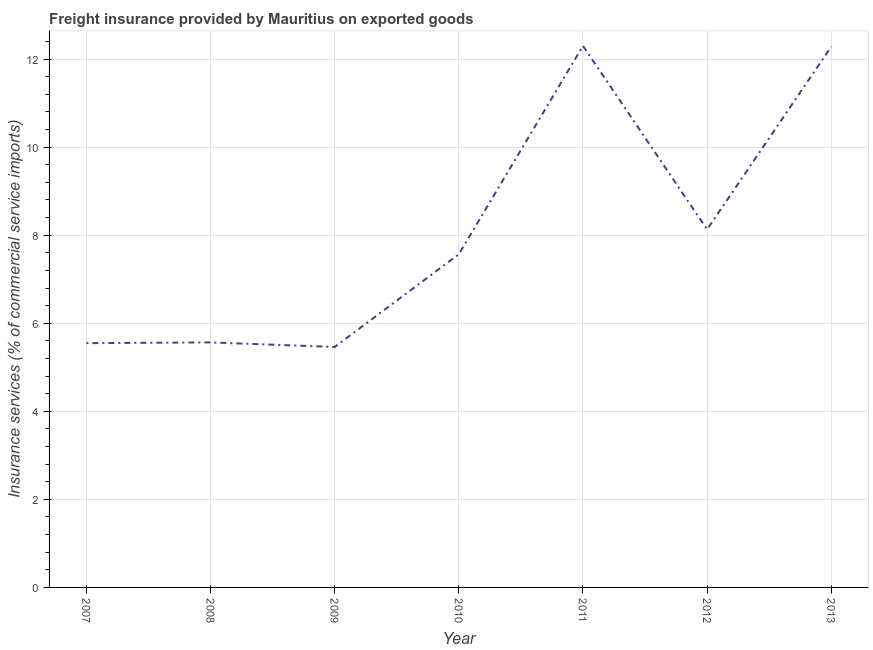What is the freight insurance in 2010?
Ensure brevity in your answer.  7.57. Across all years, what is the maximum freight insurance?
Keep it short and to the point. 12.3. Across all years, what is the minimum freight insurance?
Offer a terse response. 5.46. In which year was the freight insurance minimum?
Your answer should be very brief. 2009. What is the sum of the freight insurance?
Offer a terse response. 56.86. What is the difference between the freight insurance in 2009 and 2011?
Your response must be concise. -6.84. What is the average freight insurance per year?
Your answer should be compact. 8.12. What is the median freight insurance?
Your response must be concise. 7.57. Do a majority of the years between 2013 and 2010 (inclusive) have freight insurance greater than 3.6 %?
Give a very brief answer. Yes. What is the ratio of the freight insurance in 2007 to that in 2010?
Your answer should be very brief. 0.73. What is the difference between the highest and the second highest freight insurance?
Offer a terse response. 0.02. Is the sum of the freight insurance in 2011 and 2013 greater than the maximum freight insurance across all years?
Your answer should be compact. Yes. What is the difference between the highest and the lowest freight insurance?
Ensure brevity in your answer.  6.84. Does the freight insurance monotonically increase over the years?
Your answer should be very brief. No. What is the difference between two consecutive major ticks on the Y-axis?
Offer a terse response. 2. Does the graph contain grids?
Ensure brevity in your answer.  Yes. What is the title of the graph?
Keep it short and to the point. Freight insurance provided by Mauritius on exported goods . What is the label or title of the Y-axis?
Give a very brief answer. Insurance services (% of commercial service imports). What is the Insurance services (% of commercial service imports) of 2007?
Make the answer very short. 5.55. What is the Insurance services (% of commercial service imports) in 2008?
Your answer should be very brief. 5.56. What is the Insurance services (% of commercial service imports) of 2009?
Provide a succinct answer. 5.46. What is the Insurance services (% of commercial service imports) in 2010?
Ensure brevity in your answer.  7.57. What is the Insurance services (% of commercial service imports) in 2011?
Your answer should be very brief. 12.3. What is the Insurance services (% of commercial service imports) in 2012?
Ensure brevity in your answer.  8.13. What is the Insurance services (% of commercial service imports) in 2013?
Give a very brief answer. 12.28. What is the difference between the Insurance services (% of commercial service imports) in 2007 and 2008?
Ensure brevity in your answer.  -0.02. What is the difference between the Insurance services (% of commercial service imports) in 2007 and 2009?
Keep it short and to the point. 0.09. What is the difference between the Insurance services (% of commercial service imports) in 2007 and 2010?
Provide a succinct answer. -2.02. What is the difference between the Insurance services (% of commercial service imports) in 2007 and 2011?
Offer a very short reply. -6.75. What is the difference between the Insurance services (% of commercial service imports) in 2007 and 2012?
Your answer should be compact. -2.58. What is the difference between the Insurance services (% of commercial service imports) in 2007 and 2013?
Offer a very short reply. -6.73. What is the difference between the Insurance services (% of commercial service imports) in 2008 and 2009?
Your answer should be very brief. 0.1. What is the difference between the Insurance services (% of commercial service imports) in 2008 and 2010?
Your answer should be compact. -2. What is the difference between the Insurance services (% of commercial service imports) in 2008 and 2011?
Ensure brevity in your answer.  -6.73. What is the difference between the Insurance services (% of commercial service imports) in 2008 and 2012?
Make the answer very short. -2.57. What is the difference between the Insurance services (% of commercial service imports) in 2008 and 2013?
Offer a very short reply. -6.72. What is the difference between the Insurance services (% of commercial service imports) in 2009 and 2010?
Provide a succinct answer. -2.11. What is the difference between the Insurance services (% of commercial service imports) in 2009 and 2011?
Keep it short and to the point. -6.84. What is the difference between the Insurance services (% of commercial service imports) in 2009 and 2012?
Offer a very short reply. -2.67. What is the difference between the Insurance services (% of commercial service imports) in 2009 and 2013?
Make the answer very short. -6.82. What is the difference between the Insurance services (% of commercial service imports) in 2010 and 2011?
Your answer should be very brief. -4.73. What is the difference between the Insurance services (% of commercial service imports) in 2010 and 2012?
Your answer should be very brief. -0.56. What is the difference between the Insurance services (% of commercial service imports) in 2010 and 2013?
Your answer should be very brief. -4.72. What is the difference between the Insurance services (% of commercial service imports) in 2011 and 2012?
Keep it short and to the point. 4.17. What is the difference between the Insurance services (% of commercial service imports) in 2011 and 2013?
Keep it short and to the point. 0.02. What is the difference between the Insurance services (% of commercial service imports) in 2012 and 2013?
Your answer should be compact. -4.15. What is the ratio of the Insurance services (% of commercial service imports) in 2007 to that in 2010?
Provide a succinct answer. 0.73. What is the ratio of the Insurance services (% of commercial service imports) in 2007 to that in 2011?
Provide a short and direct response. 0.45. What is the ratio of the Insurance services (% of commercial service imports) in 2007 to that in 2012?
Provide a succinct answer. 0.68. What is the ratio of the Insurance services (% of commercial service imports) in 2007 to that in 2013?
Offer a very short reply. 0.45. What is the ratio of the Insurance services (% of commercial service imports) in 2008 to that in 2010?
Your answer should be compact. 0.73. What is the ratio of the Insurance services (% of commercial service imports) in 2008 to that in 2011?
Your answer should be very brief. 0.45. What is the ratio of the Insurance services (% of commercial service imports) in 2008 to that in 2012?
Give a very brief answer. 0.68. What is the ratio of the Insurance services (% of commercial service imports) in 2008 to that in 2013?
Provide a succinct answer. 0.45. What is the ratio of the Insurance services (% of commercial service imports) in 2009 to that in 2010?
Ensure brevity in your answer.  0.72. What is the ratio of the Insurance services (% of commercial service imports) in 2009 to that in 2011?
Your answer should be very brief. 0.44. What is the ratio of the Insurance services (% of commercial service imports) in 2009 to that in 2012?
Make the answer very short. 0.67. What is the ratio of the Insurance services (% of commercial service imports) in 2009 to that in 2013?
Offer a terse response. 0.45. What is the ratio of the Insurance services (% of commercial service imports) in 2010 to that in 2011?
Offer a very short reply. 0.61. What is the ratio of the Insurance services (% of commercial service imports) in 2010 to that in 2012?
Offer a terse response. 0.93. What is the ratio of the Insurance services (% of commercial service imports) in 2010 to that in 2013?
Your response must be concise. 0.62. What is the ratio of the Insurance services (% of commercial service imports) in 2011 to that in 2012?
Provide a succinct answer. 1.51. What is the ratio of the Insurance services (% of commercial service imports) in 2012 to that in 2013?
Your response must be concise. 0.66. 